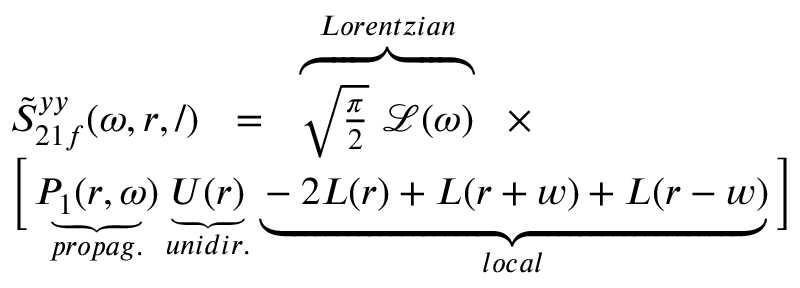<formula> <loc_0><loc_0><loc_500><loc_500>\begin{array} { r l } & { \tilde { S } _ { 2 1 f } ^ { y y } ( \omega , r , / ) = \overbrace { \sqrt { \frac { \pi } { 2 } } \mathcal { L } ( \omega ) } ^ { L o r e n t z i a n } \times } \\ & { \left [ \underbrace { P _ { 1 } ( r , \omega ) } _ { p r o p a g . } \underbrace { U ( r ) } _ { u n i d i r . } \underbrace { - 2 L ( r ) + L ( r + w ) + L ( r - w ) } _ { l o c a l } \right ] } \end{array}</formula> 